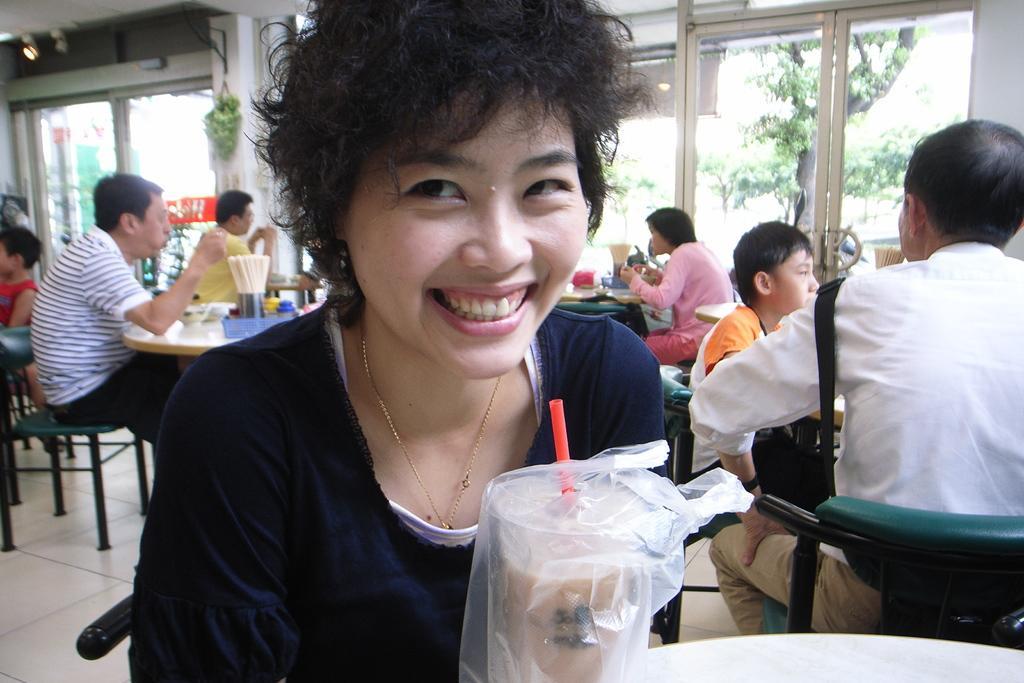How would you summarize this image in a sentence or two? In this image there are persons sitting on the chair, there are tables, there is a table truncated towards the bottom of the image, there is a chair truncated towards the right of the image, there are objects on the table, there is the door, there is the wall truncated towards the right of the image, there is a plant on the wall, there are lights, there is roof truncated towards the top of the image, there is a person truncated towards the left of the image, there is a chair truncated towards the left of the image. 